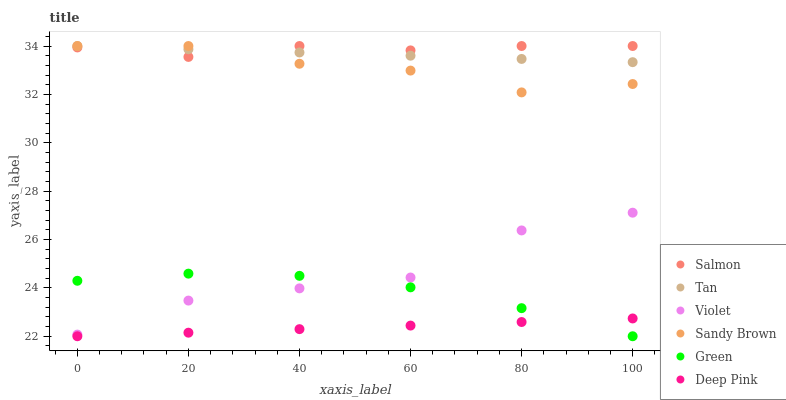Does Deep Pink have the minimum area under the curve?
Answer yes or no. Yes. Does Salmon have the maximum area under the curve?
Answer yes or no. Yes. Does Green have the minimum area under the curve?
Answer yes or no. No. Does Green have the maximum area under the curve?
Answer yes or no. No. Is Deep Pink the smoothest?
Answer yes or no. Yes. Is Violet the roughest?
Answer yes or no. Yes. Is Salmon the smoothest?
Answer yes or no. No. Is Salmon the roughest?
Answer yes or no. No. Does Deep Pink have the lowest value?
Answer yes or no. Yes. Does Salmon have the lowest value?
Answer yes or no. No. Does Sandy Brown have the highest value?
Answer yes or no. Yes. Does Green have the highest value?
Answer yes or no. No. Is Violet less than Tan?
Answer yes or no. Yes. Is Violet greater than Deep Pink?
Answer yes or no. Yes. Does Tan intersect Sandy Brown?
Answer yes or no. Yes. Is Tan less than Sandy Brown?
Answer yes or no. No. Is Tan greater than Sandy Brown?
Answer yes or no. No. Does Violet intersect Tan?
Answer yes or no. No. 